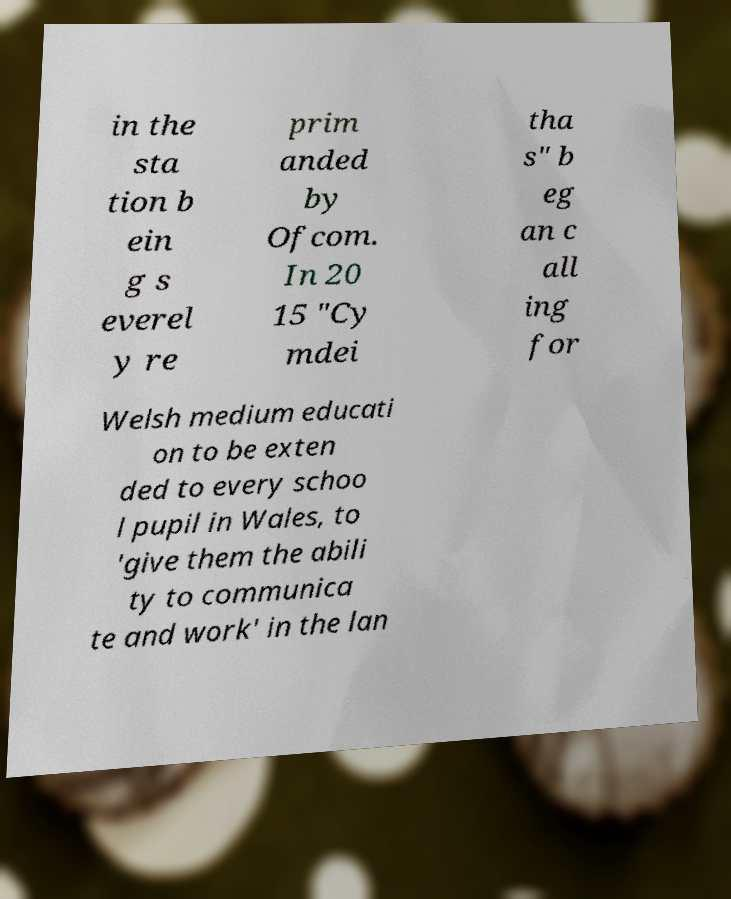Please identify and transcribe the text found in this image. in the sta tion b ein g s everel y re prim anded by Ofcom. In 20 15 "Cy mdei tha s" b eg an c all ing for Welsh medium educati on to be exten ded to every schoo l pupil in Wales, to 'give them the abili ty to communica te and work' in the lan 